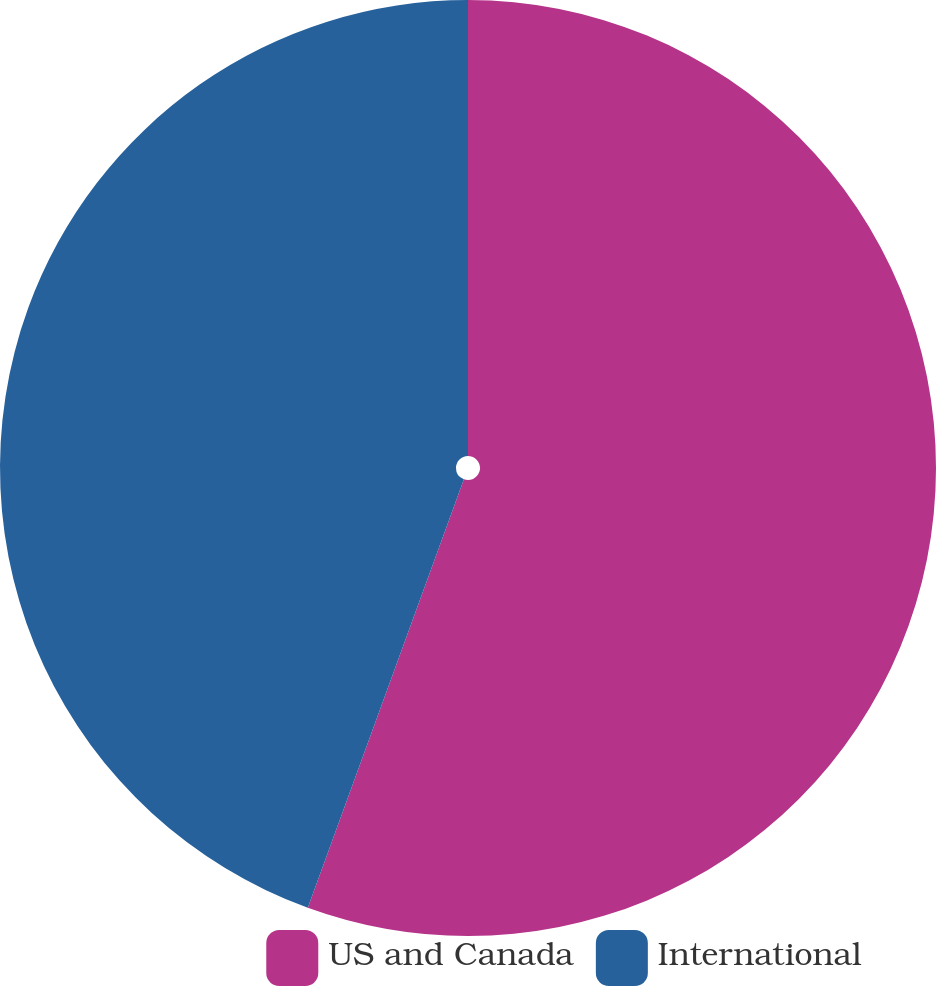<chart> <loc_0><loc_0><loc_500><loc_500><pie_chart><fcel>US and Canada<fcel>International<nl><fcel>55.56%<fcel>44.44%<nl></chart> 